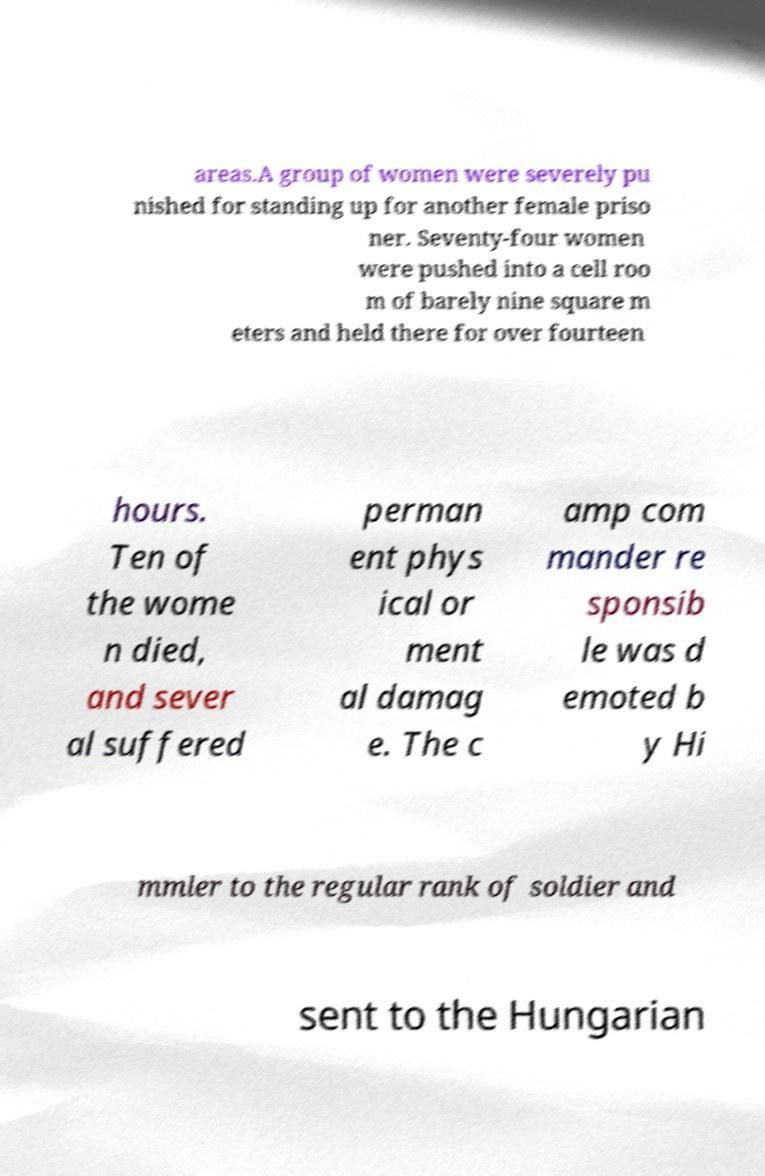Please identify and transcribe the text found in this image. areas.A group of women were severely pu nished for standing up for another female priso ner. Seventy-four women were pushed into a cell roo m of barely nine square m eters and held there for over fourteen hours. Ten of the wome n died, and sever al suffered perman ent phys ical or ment al damag e. The c amp com mander re sponsib le was d emoted b y Hi mmler to the regular rank of soldier and sent to the Hungarian 